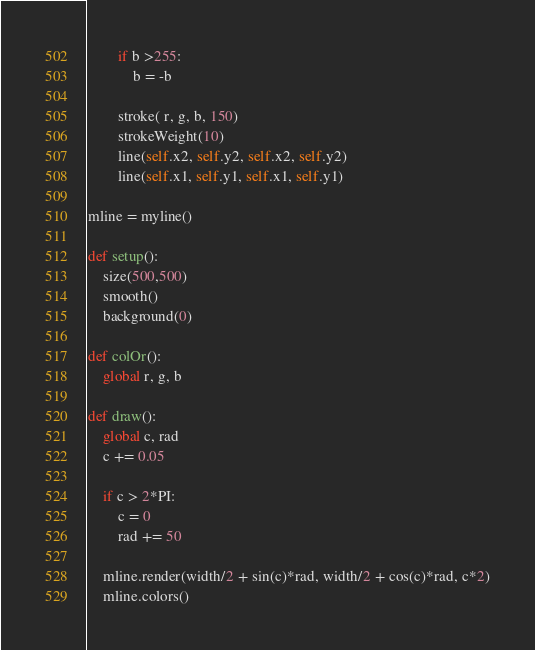Convert code to text. <code><loc_0><loc_0><loc_500><loc_500><_Python_>        if b >255:
            b = -b
            
        stroke( r, g, b, 150)
        strokeWeight(10)
        line(self.x2, self.y2, self.x2, self.y2)
        line(self.x1, self.y1, self.x1, self.y1)

mline = myline()

def setup():
    size(500,500)
    smooth()
    background(0)
    
def colOr():
    global r, g, b

def draw():
    global c, rad
    c += 0.05
    
    if c > 2*PI:
        c = 0
        rad += 50
        
    mline.render(width/2 + sin(c)*rad, width/2 + cos(c)*rad, c*2)
    mline.colors()
</code> 